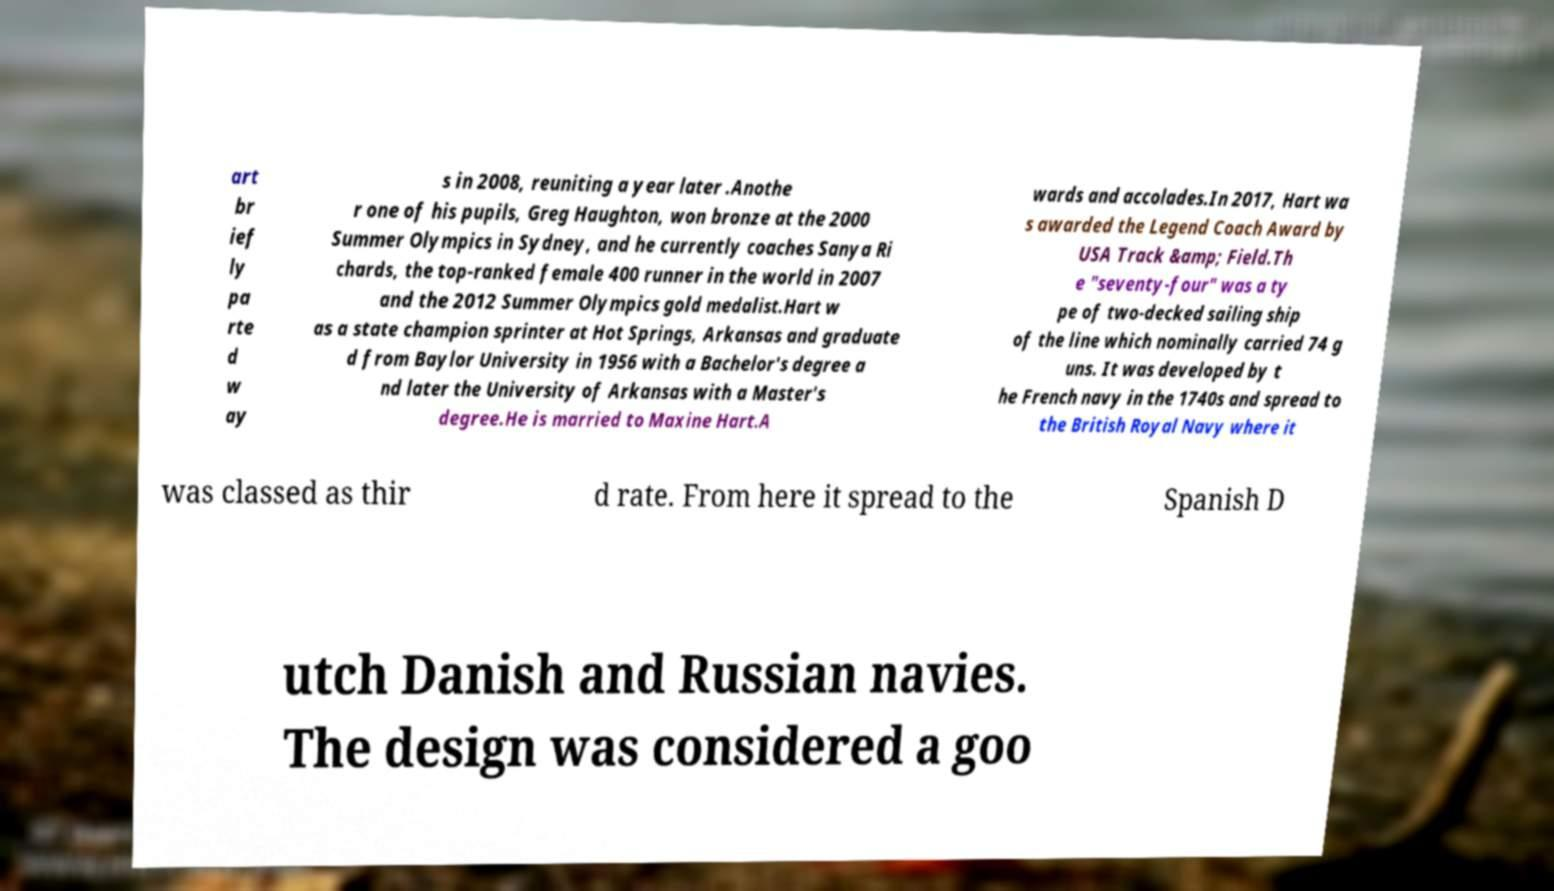Could you extract and type out the text from this image? art br ief ly pa rte d w ay s in 2008, reuniting a year later .Anothe r one of his pupils, Greg Haughton, won bronze at the 2000 Summer Olympics in Sydney, and he currently coaches Sanya Ri chards, the top-ranked female 400 runner in the world in 2007 and the 2012 Summer Olympics gold medalist.Hart w as a state champion sprinter at Hot Springs, Arkansas and graduate d from Baylor University in 1956 with a Bachelor's degree a nd later the University of Arkansas with a Master's degree.He is married to Maxine Hart.A wards and accolades.In 2017, Hart wa s awarded the Legend Coach Award by USA Track &amp; Field.Th e "seventy-four" was a ty pe of two-decked sailing ship of the line which nominally carried 74 g uns. It was developed by t he French navy in the 1740s and spread to the British Royal Navy where it was classed as thir d rate. From here it spread to the Spanish D utch Danish and Russian navies. The design was considered a goo 